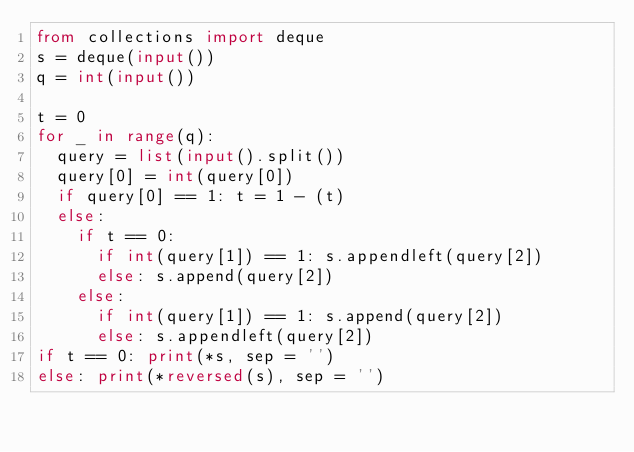<code> <loc_0><loc_0><loc_500><loc_500><_Python_>from collections import deque
s = deque(input())
q = int(input())

t = 0
for _ in range(q):
  query = list(input().split())
  query[0] = int(query[0])
  if query[0] == 1: t = 1 - (t)
  else:
    if t == 0:
      if int(query[1]) == 1: s.appendleft(query[2])
      else: s.append(query[2])
    else:
      if int(query[1]) == 1: s.append(query[2])
      else: s.appendleft(query[2])
if t == 0: print(*s, sep = '')
else: print(*reversed(s), sep = '')</code> 